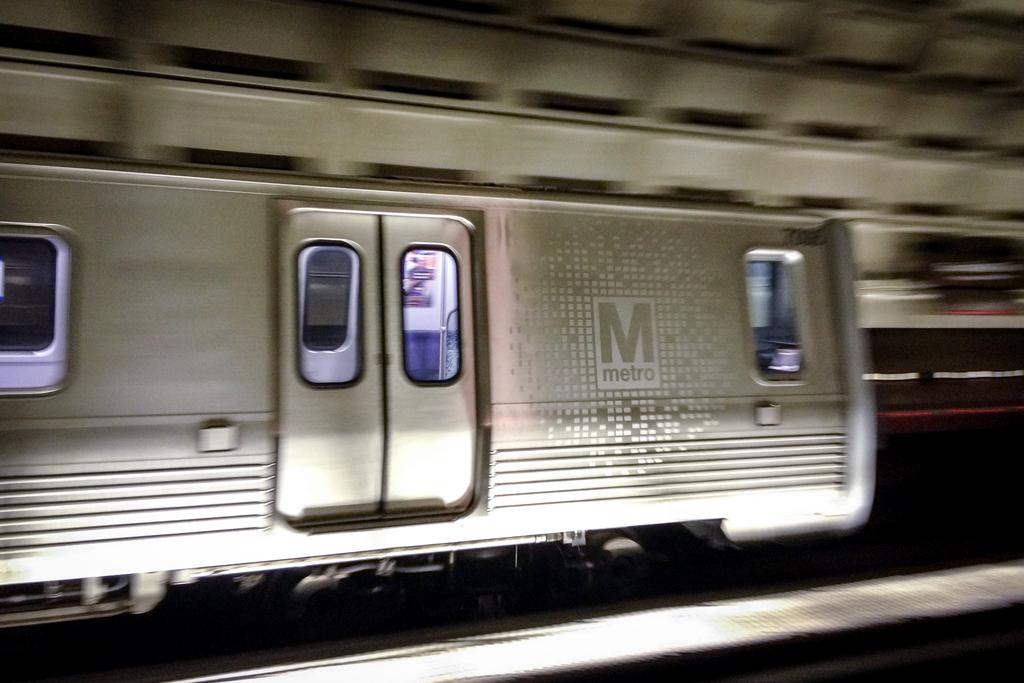Provide a one-sentence caption for the provided image. A subway car is in a station and has a metro logo on the side. 